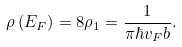<formula> <loc_0><loc_0><loc_500><loc_500>\rho \left ( E _ { F } \right ) = 8 \rho _ { 1 } = \frac { 1 } { \pi \hbar { v } _ { F } b } .</formula> 